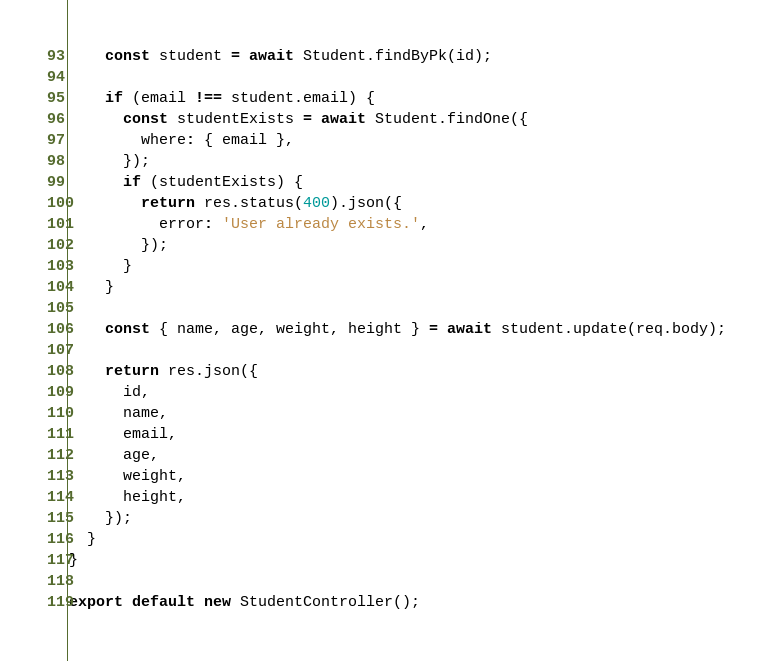<code> <loc_0><loc_0><loc_500><loc_500><_JavaScript_>    const student = await Student.findByPk(id);

    if (email !== student.email) {
      const studentExists = await Student.findOne({
        where: { email },
      });
      if (studentExists) {
        return res.status(400).json({
          error: 'User already exists.',
        });
      }
    }

    const { name, age, weight, height } = await student.update(req.body);

    return res.json({
      id,
      name,
      email,
      age,
      weight,
      height,
    });
  }
}

export default new StudentController();
</code> 